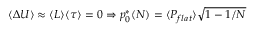<formula> <loc_0><loc_0><loc_500><loc_500>\langle \Delta U \rangle \approx \langle L \rangle \langle \tau \rangle = 0 \Rightarrow p _ { 0 } ^ { * } ( N ) = \langle P _ { f l a t } \rangle \sqrt { 1 - 1 / N }</formula> 